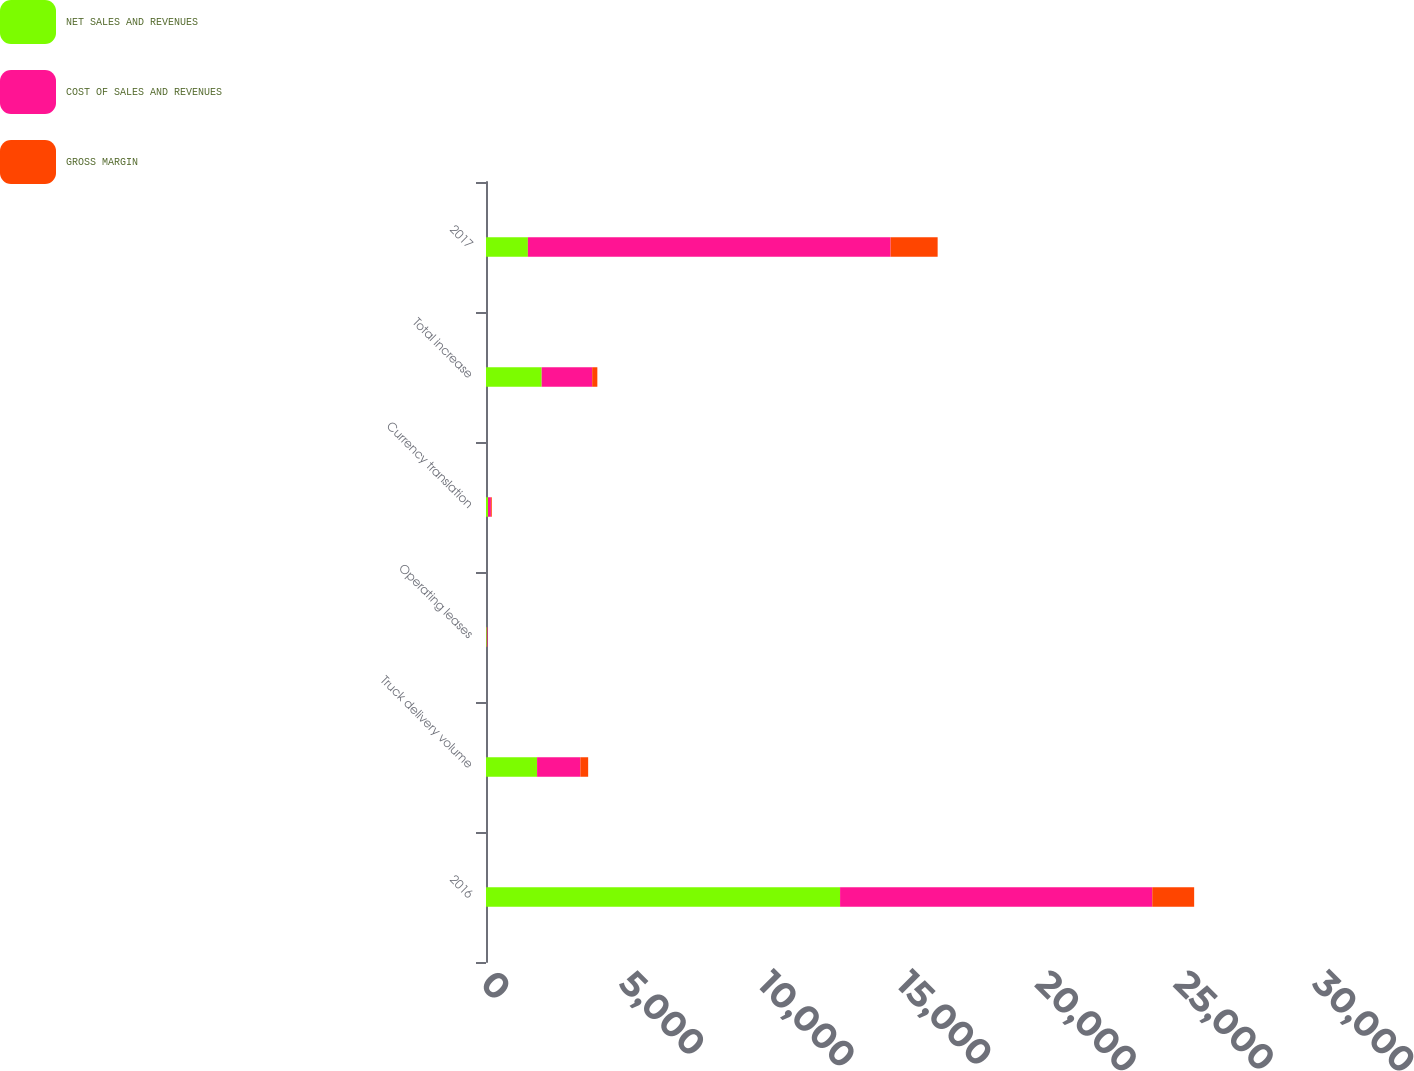Convert chart. <chart><loc_0><loc_0><loc_500><loc_500><stacked_bar_chart><ecel><fcel>2016<fcel>Truck delivery volume<fcel>Operating leases<fcel>Currency translation<fcel>Total increase<fcel>2017<nl><fcel>NET SALES AND REVENUES<fcel>12767.3<fcel>1841.9<fcel>28.1<fcel>72.1<fcel>2007.5<fcel>1510.5<nl><fcel>COST OF SALES AND REVENUES<fcel>11256.8<fcel>1559.7<fcel>25.2<fcel>104.1<fcel>1820.7<fcel>13077.5<nl><fcel>GROSS MARGIN<fcel>1510.5<fcel>282.2<fcel>2.9<fcel>32<fcel>186.8<fcel>1697.3<nl></chart> 